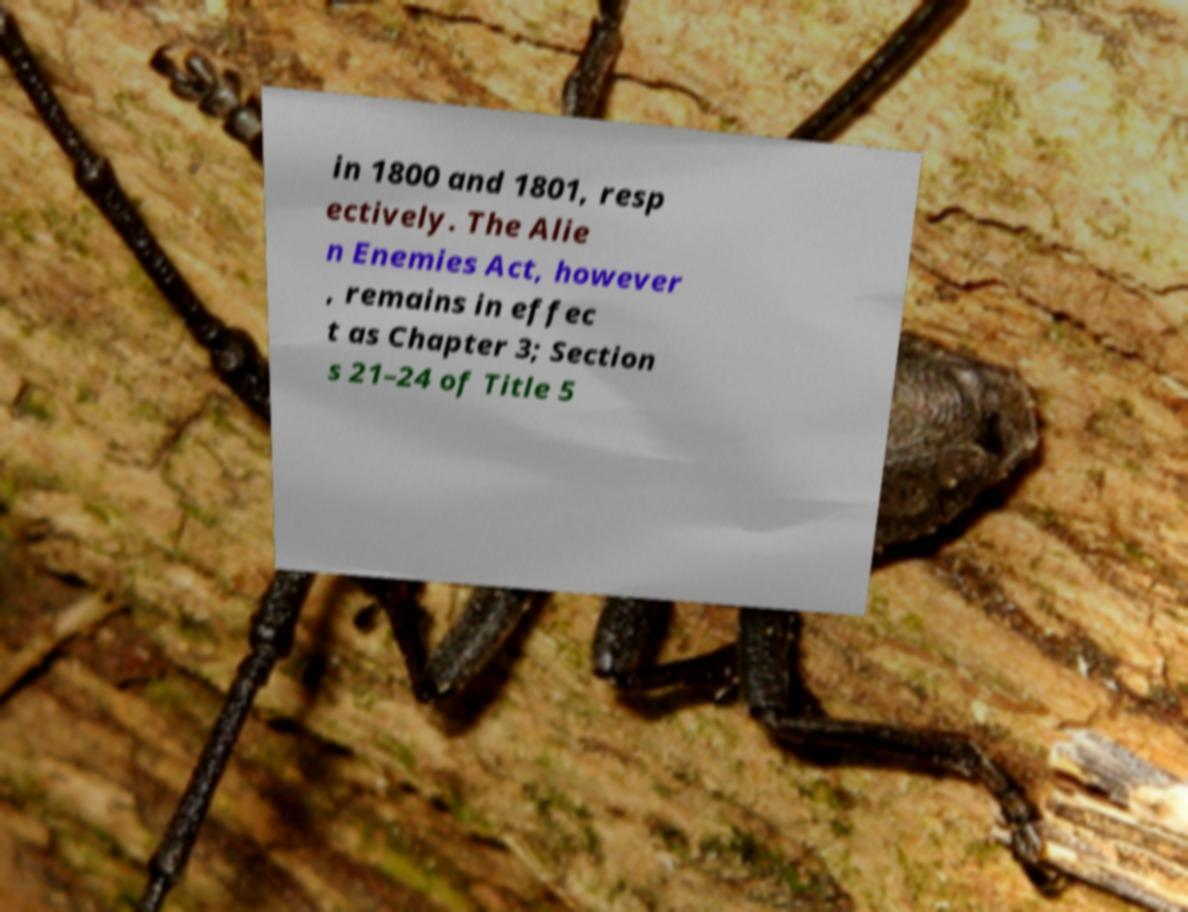For documentation purposes, I need the text within this image transcribed. Could you provide that? in 1800 and 1801, resp ectively. The Alie n Enemies Act, however , remains in effec t as Chapter 3; Section s 21–24 of Title 5 